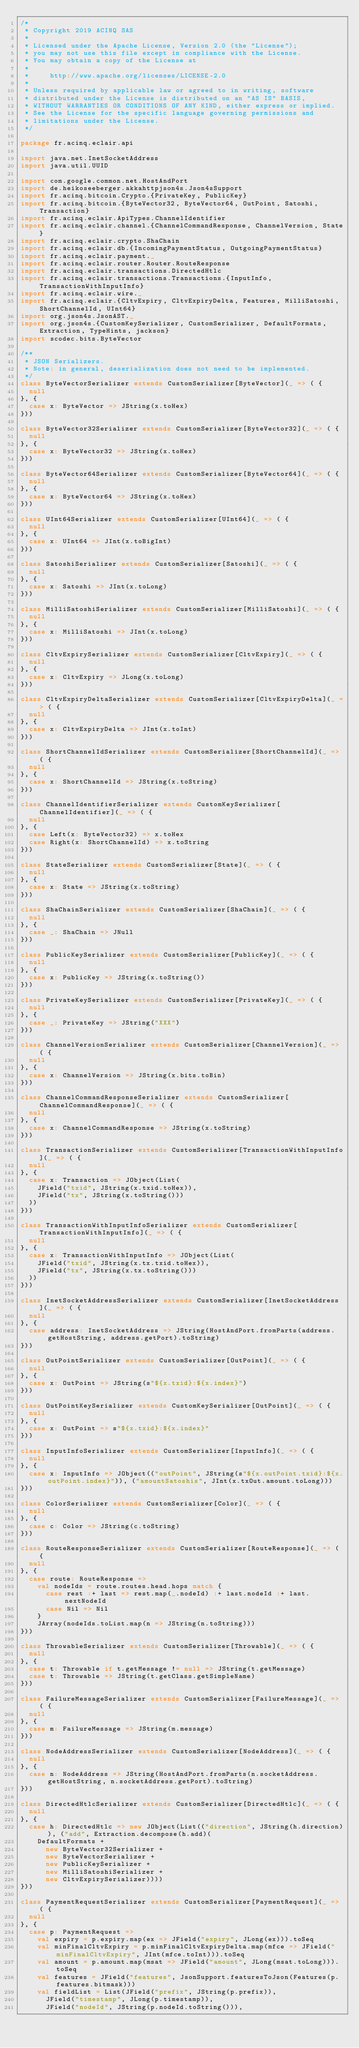Convert code to text. <code><loc_0><loc_0><loc_500><loc_500><_Scala_>/*
 * Copyright 2019 ACINQ SAS
 *
 * Licensed under the Apache License, Version 2.0 (the "License");
 * you may not use this file except in compliance with the License.
 * You may obtain a copy of the License at
 *
 *     http://www.apache.org/licenses/LICENSE-2.0
 *
 * Unless required by applicable law or agreed to in writing, software
 * distributed under the License is distributed on an "AS IS" BASIS,
 * WITHOUT WARRANTIES OR CONDITIONS OF ANY KIND, either express or implied.
 * See the License for the specific language governing permissions and
 * limitations under the License.
 */

package fr.acinq.eclair.api

import java.net.InetSocketAddress
import java.util.UUID

import com.google.common.net.HostAndPort
import de.heikoseeberger.akkahttpjson4s.Json4sSupport
import fr.acinq.bitcoin.Crypto.{PrivateKey, PublicKey}
import fr.acinq.bitcoin.{ByteVector32, ByteVector64, OutPoint, Satoshi, Transaction}
import fr.acinq.eclair.ApiTypes.ChannelIdentifier
import fr.acinq.eclair.channel.{ChannelCommandResponse, ChannelVersion, State}
import fr.acinq.eclair.crypto.ShaChain
import fr.acinq.eclair.db.{IncomingPaymentStatus, OutgoingPaymentStatus}
import fr.acinq.eclair.payment._
import fr.acinq.eclair.router.Router.RouteResponse
import fr.acinq.eclair.transactions.DirectedHtlc
import fr.acinq.eclair.transactions.Transactions.{InputInfo, TransactionWithInputInfo}
import fr.acinq.eclair.wire._
import fr.acinq.eclair.{CltvExpiry, CltvExpiryDelta, Features, MilliSatoshi, ShortChannelId, UInt64}
import org.json4s.JsonAST._
import org.json4s.{CustomKeySerializer, CustomSerializer, DefaultFormats, Extraction, TypeHints, jackson}
import scodec.bits.ByteVector

/**
 * JSON Serializers.
 * Note: in general, deserialization does not need to be implemented.
 */
class ByteVectorSerializer extends CustomSerializer[ByteVector](_ => ( {
  null
}, {
  case x: ByteVector => JString(x.toHex)
}))

class ByteVector32Serializer extends CustomSerializer[ByteVector32](_ => ( {
  null
}, {
  case x: ByteVector32 => JString(x.toHex)
}))

class ByteVector64Serializer extends CustomSerializer[ByteVector64](_ => ( {
  null
}, {
  case x: ByteVector64 => JString(x.toHex)
}))

class UInt64Serializer extends CustomSerializer[UInt64](_ => ( {
  null
}, {
  case x: UInt64 => JInt(x.toBigInt)
}))

class SatoshiSerializer extends CustomSerializer[Satoshi](_ => ( {
  null
}, {
  case x: Satoshi => JInt(x.toLong)
}))

class MilliSatoshiSerializer extends CustomSerializer[MilliSatoshi](_ => ( {
  null
}, {
  case x: MilliSatoshi => JInt(x.toLong)
}))

class CltvExpirySerializer extends CustomSerializer[CltvExpiry](_ => ( {
  null
}, {
  case x: CltvExpiry => JLong(x.toLong)
}))

class CltvExpiryDeltaSerializer extends CustomSerializer[CltvExpiryDelta](_ => ( {
  null
}, {
  case x: CltvExpiryDelta => JInt(x.toInt)
}))

class ShortChannelIdSerializer extends CustomSerializer[ShortChannelId](_ => ( {
  null
}, {
  case x: ShortChannelId => JString(x.toString)
}))

class ChannelIdentifierSerializer extends CustomKeySerializer[ChannelIdentifier](_ => ( {
  null
}, {
  case Left(x: ByteVector32) => x.toHex
  case Right(x: ShortChannelId) => x.toString
}))

class StateSerializer extends CustomSerializer[State](_ => ( {
  null
}, {
  case x: State => JString(x.toString)
}))

class ShaChainSerializer extends CustomSerializer[ShaChain](_ => ( {
  null
}, {
  case _: ShaChain => JNull
}))

class PublicKeySerializer extends CustomSerializer[PublicKey](_ => ( {
  null
}, {
  case x: PublicKey => JString(x.toString())
}))

class PrivateKeySerializer extends CustomSerializer[PrivateKey](_ => ( {
  null
}, {
  case _: PrivateKey => JString("XXX")
}))

class ChannelVersionSerializer extends CustomSerializer[ChannelVersion](_ => ( {
  null
}, {
  case x: ChannelVersion => JString(x.bits.toBin)
}))

class ChannelCommandResponseSerializer extends CustomSerializer[ChannelCommandResponse](_ => ( {
  null
}, {
  case x: ChannelCommandResponse => JString(x.toString)
}))

class TransactionSerializer extends CustomSerializer[TransactionWithInputInfo](_ => ( {
  null
}, {
  case x: Transaction => JObject(List(
    JField("txid", JString(x.txid.toHex)),
    JField("tx", JString(x.toString()))
  ))
}))

class TransactionWithInputInfoSerializer extends CustomSerializer[TransactionWithInputInfo](_ => ( {
  null
}, {
  case x: TransactionWithInputInfo => JObject(List(
    JField("txid", JString(x.tx.txid.toHex)),
    JField("tx", JString(x.tx.toString()))
  ))
}))

class InetSocketAddressSerializer extends CustomSerializer[InetSocketAddress](_ => ( {
  null
}, {
  case address: InetSocketAddress => JString(HostAndPort.fromParts(address.getHostString, address.getPort).toString)
}))

class OutPointSerializer extends CustomSerializer[OutPoint](_ => ( {
  null
}, {
  case x: OutPoint => JString(s"${x.txid}:${x.index}")
}))

class OutPointKeySerializer extends CustomKeySerializer[OutPoint](_ => ( {
  null
}, {
  case x: OutPoint => s"${x.txid}:${x.index}"
}))

class InputInfoSerializer extends CustomSerializer[InputInfo](_ => ( {
  null
}, {
  case x: InputInfo => JObject(("outPoint", JString(s"${x.outPoint.txid}:${x.outPoint.index}")), ("amountSatoshis", JInt(x.txOut.amount.toLong)))
}))

class ColorSerializer extends CustomSerializer[Color](_ => ( {
  null
}, {
  case c: Color => JString(c.toString)
}))

class RouteResponseSerializer extends CustomSerializer[RouteResponse](_ => ( {
  null
}, {
  case route: RouteResponse =>
    val nodeIds = route.routes.head.hops match {
      case rest :+ last => rest.map(_.nodeId) :+ last.nodeId :+ last.nextNodeId
      case Nil => Nil
    }
    JArray(nodeIds.toList.map(n => JString(n.toString)))
}))

class ThrowableSerializer extends CustomSerializer[Throwable](_ => ( {
  null
}, {
  case t: Throwable if t.getMessage != null => JString(t.getMessage)
  case t: Throwable => JString(t.getClass.getSimpleName)
}))

class FailureMessageSerializer extends CustomSerializer[FailureMessage](_ => ( {
  null
}, {
  case m: FailureMessage => JString(m.message)
}))

class NodeAddressSerializer extends CustomSerializer[NodeAddress](_ => ( {
  null
}, {
  case n: NodeAddress => JString(HostAndPort.fromParts(n.socketAddress.getHostString, n.socketAddress.getPort).toString)
}))

class DirectedHtlcSerializer extends CustomSerializer[DirectedHtlc](_ => ( {
  null
}, {
  case h: DirectedHtlc => new JObject(List(("direction", JString(h.direction)), ("add", Extraction.decompose(h.add)(
    DefaultFormats +
      new ByteVector32Serializer +
      new ByteVectorSerializer +
      new PublicKeySerializer +
      new MilliSatoshiSerializer +
      new CltvExpirySerializer))))
}))

class PaymentRequestSerializer extends CustomSerializer[PaymentRequest](_ => ( {
  null
}, {
  case p: PaymentRequest =>
    val expiry = p.expiry.map(ex => JField("expiry", JLong(ex))).toSeq
    val minFinalCltvExpiry = p.minFinalCltvExpiryDelta.map(mfce => JField("minFinalCltvExpiry", JInt(mfce.toInt))).toSeq
    val amount = p.amount.map(msat => JField("amount", JLong(msat.toLong))).toSeq
    val features = JField("features", JsonSupport.featuresToJson(Features(p.features.bitmask)))
    val fieldList = List(JField("prefix", JString(p.prefix)),
      JField("timestamp", JLong(p.timestamp)),
      JField("nodeId", JString(p.nodeId.toString())),</code> 